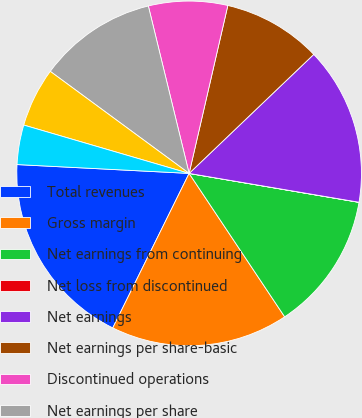Convert chart. <chart><loc_0><loc_0><loc_500><loc_500><pie_chart><fcel>Total revenues<fcel>Gross margin<fcel>Net earnings from continuing<fcel>Net loss from discontinued<fcel>Net earnings<fcel>Net earnings per share-basic<fcel>Discontinued operations<fcel>Net earnings per share<fcel>Net earnings per share-diluted<fcel>Net earnings (loss) per<nl><fcel>18.51%<fcel>16.66%<fcel>12.96%<fcel>0.01%<fcel>14.81%<fcel>9.26%<fcel>7.41%<fcel>11.11%<fcel>5.56%<fcel>3.71%<nl></chart> 